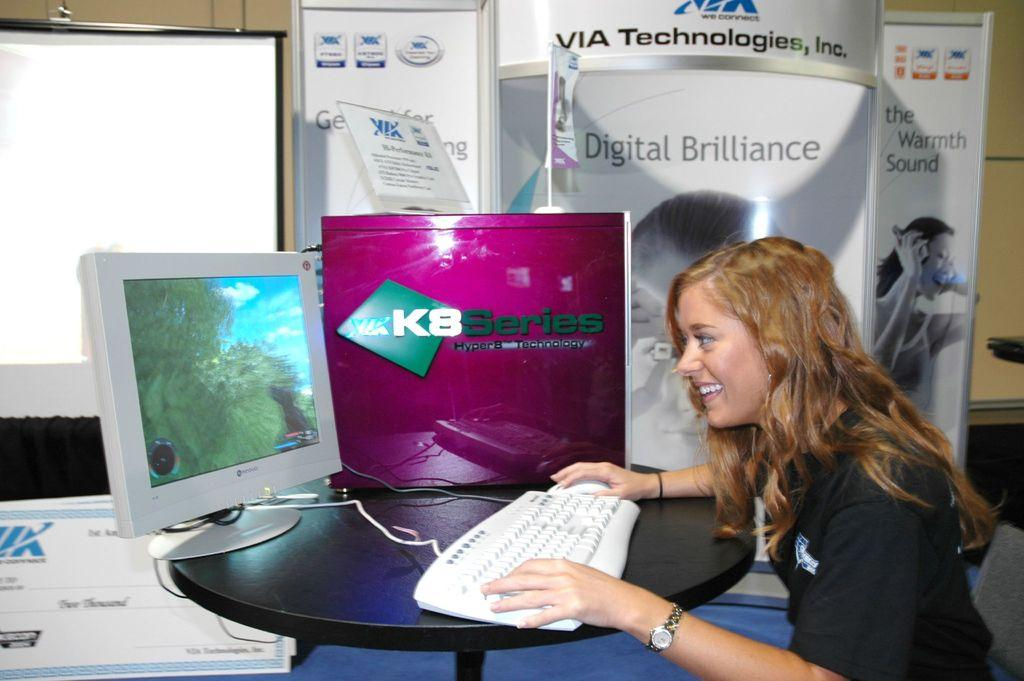<image>
Create a compact narrative representing the image presented. A girl sits at a computer in a room with VIA Technologies, Inc above a display. 